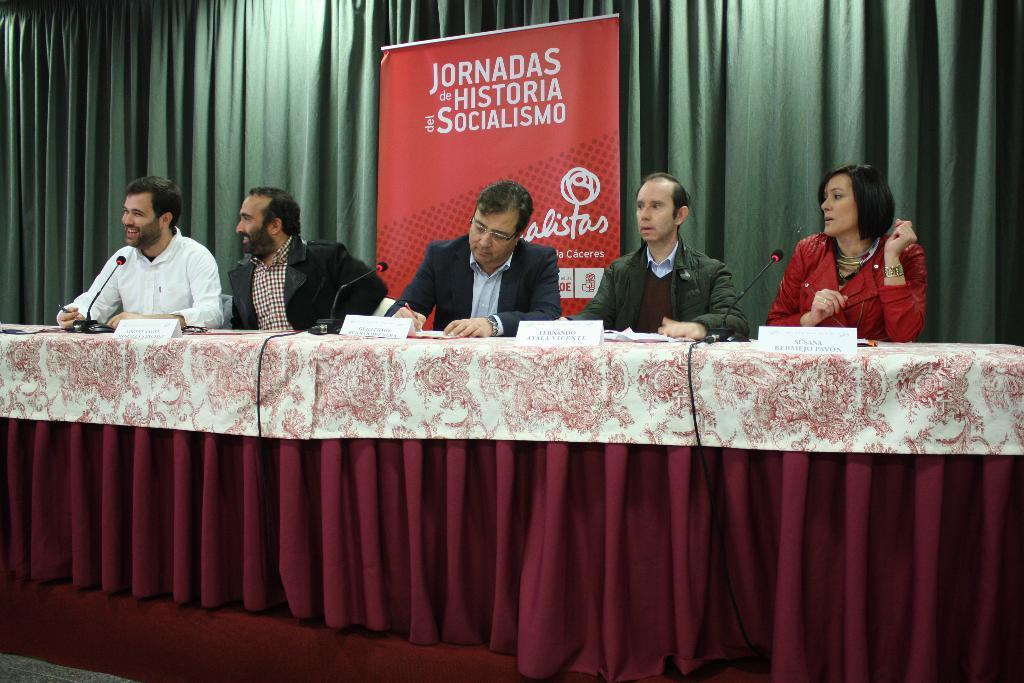Describe this image in one or two sentences. In this image there are 4 persons and 1 woman sitting in chair near the table or podium, and there are name boards , microphones and at the background there is hoarding, curtain. 